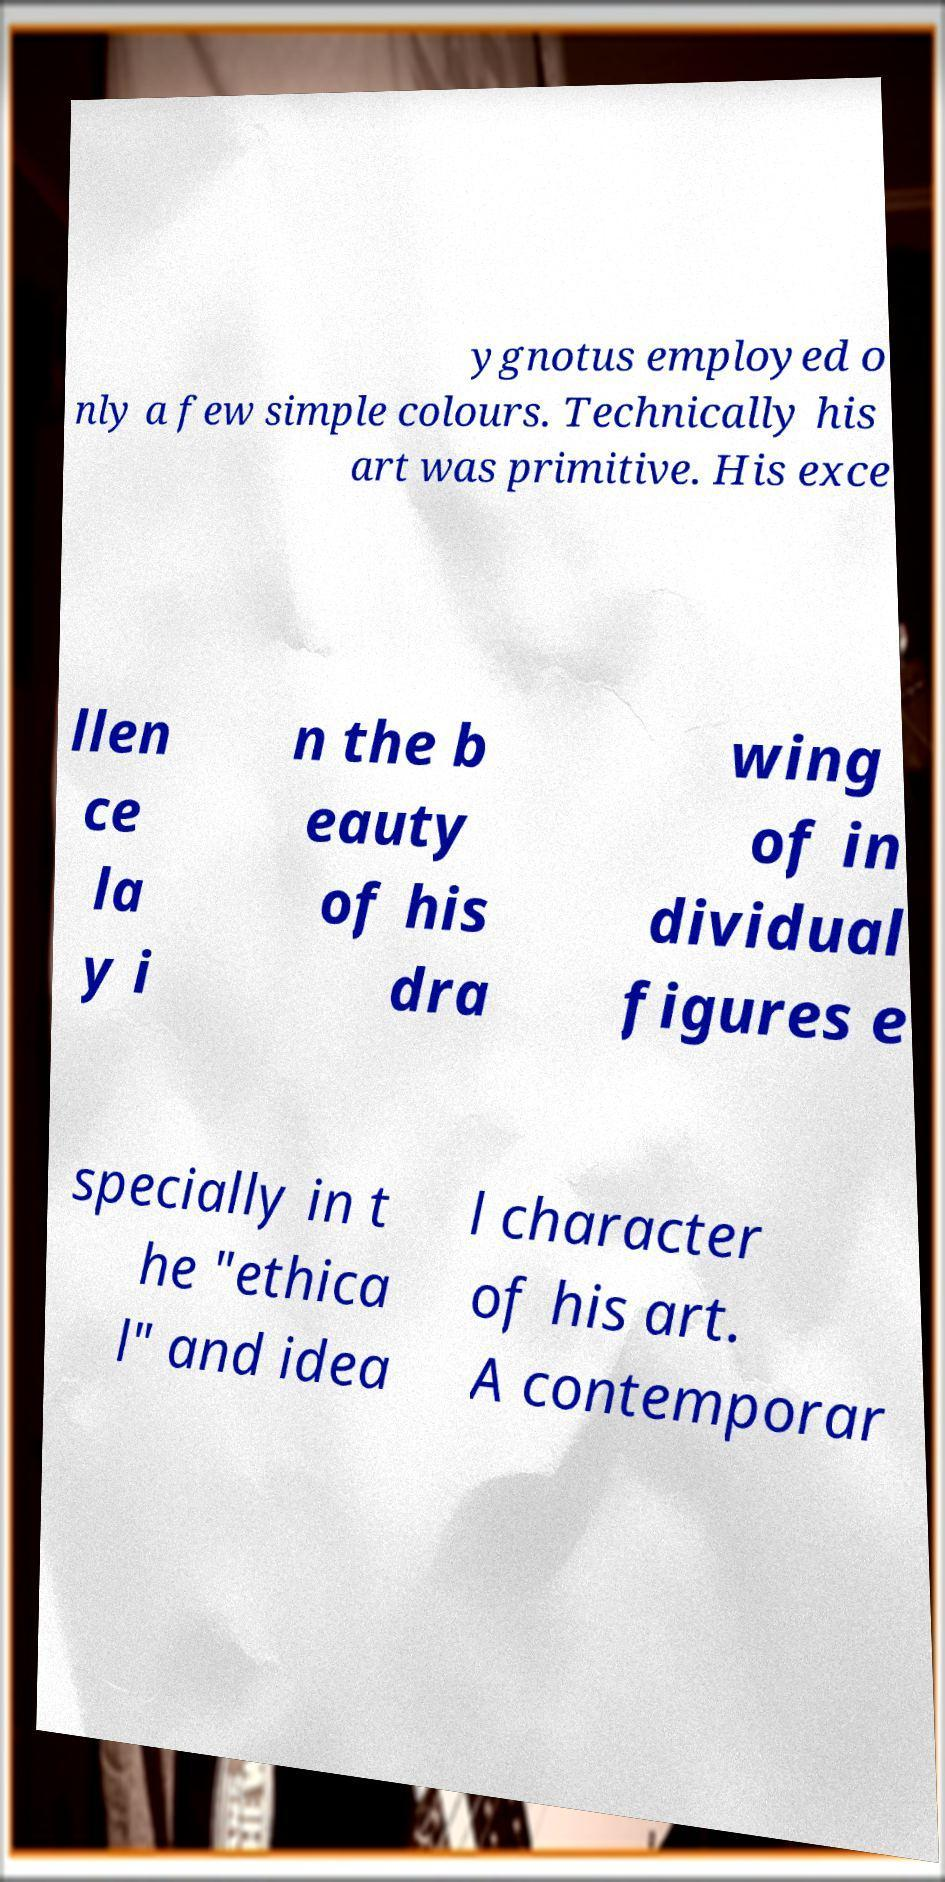Can you accurately transcribe the text from the provided image for me? ygnotus employed o nly a few simple colours. Technically his art was primitive. His exce llen ce la y i n the b eauty of his dra wing of in dividual figures e specially in t he "ethica l" and idea l character of his art. A contemporar 